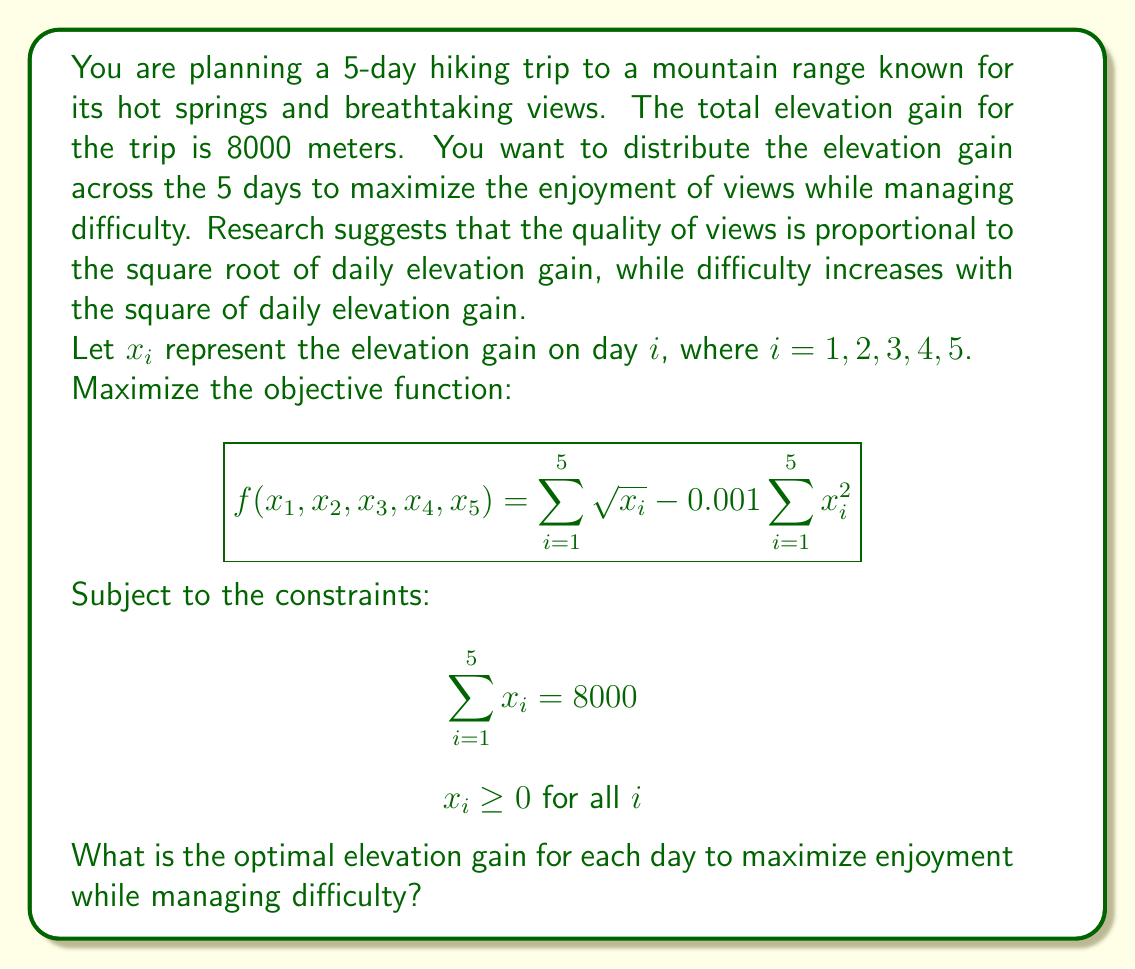Can you solve this math problem? To solve this optimization problem, we can use the method of Lagrange multipliers. 

1) First, we form the Lagrangian function:

   $$L(x_1, x_2, x_3, x_4, x_5, \lambda) = \sum_{i=1}^5 \sqrt{x_i} - 0.001\sum_{i=1}^5 x_i^2 + \lambda(8000 - \sum_{i=1}^5 x_i)$$

2) Now, we take partial derivatives with respect to each $x_i$ and set them equal to zero:

   $$\frac{\partial L}{\partial x_i} = \frac{1}{2\sqrt{x_i}} - 0.002x_i - \lambda = 0$$

3) This gives us the equation for each $x_i$:

   $$\frac{1}{2\sqrt{x_i}} - 0.002x_i = \lambda$$

4) Since this equation is the same for all $x_i$, we can conclude that all $x_i$ are equal. Let's call this common value $x$.

5) Given the constraint $\sum_{i=1}^5 x_i = 8000$, we can say:

   $$5x = 8000$$
   $$x = 1600$$

6) To verify this is indeed a maximum, we can check the second derivative, which is negative:

   $$\frac{\partial^2 L}{\partial x_i^2} = -\frac{1}{4x_i^{3/2}} - 0.002 < 0$$

Therefore, the optimal solution is to distribute the elevation gain equally across all 5 days.
Answer: The optimal elevation gain for each day is 1600 meters. 